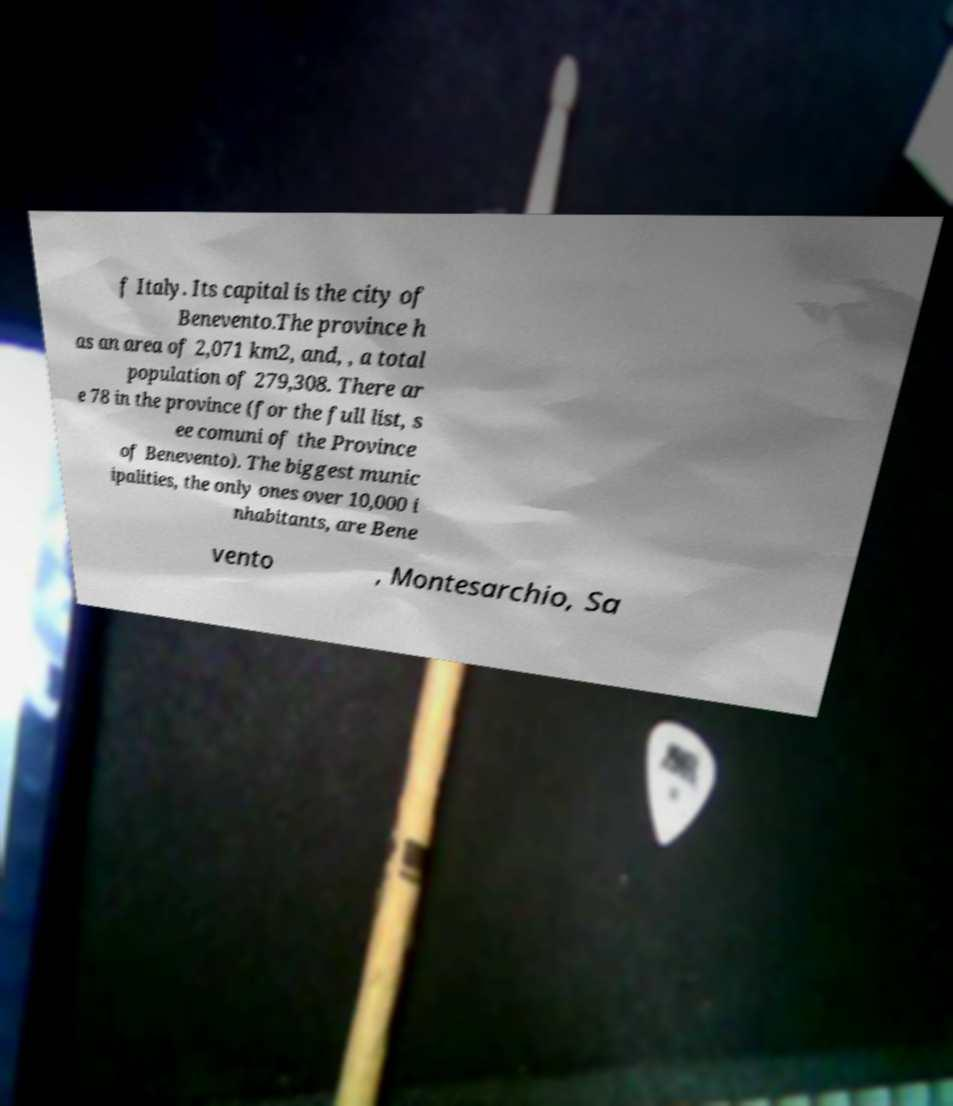What messages or text are displayed in this image? I need them in a readable, typed format. f Italy. Its capital is the city of Benevento.The province h as an area of 2,071 km2, and, , a total population of 279,308. There ar e 78 in the province (for the full list, s ee comuni of the Province of Benevento). The biggest munic ipalities, the only ones over 10,000 i nhabitants, are Bene vento , Montesarchio, Sa 